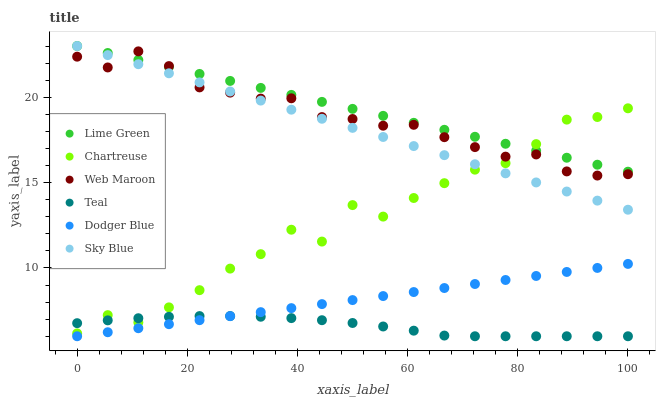Does Teal have the minimum area under the curve?
Answer yes or no. Yes. Does Lime Green have the maximum area under the curve?
Answer yes or no. Yes. Does Chartreuse have the minimum area under the curve?
Answer yes or no. No. Does Chartreuse have the maximum area under the curve?
Answer yes or no. No. Is Dodger Blue the smoothest?
Answer yes or no. Yes. Is Chartreuse the roughest?
Answer yes or no. Yes. Is Chartreuse the smoothest?
Answer yes or no. No. Is Dodger Blue the roughest?
Answer yes or no. No. Does Dodger Blue have the lowest value?
Answer yes or no. Yes. Does Chartreuse have the lowest value?
Answer yes or no. No. Does Lime Green have the highest value?
Answer yes or no. Yes. Does Chartreuse have the highest value?
Answer yes or no. No. Is Teal less than Web Maroon?
Answer yes or no. Yes. Is Sky Blue greater than Teal?
Answer yes or no. Yes. Does Chartreuse intersect Lime Green?
Answer yes or no. Yes. Is Chartreuse less than Lime Green?
Answer yes or no. No. Is Chartreuse greater than Lime Green?
Answer yes or no. No. Does Teal intersect Web Maroon?
Answer yes or no. No. 